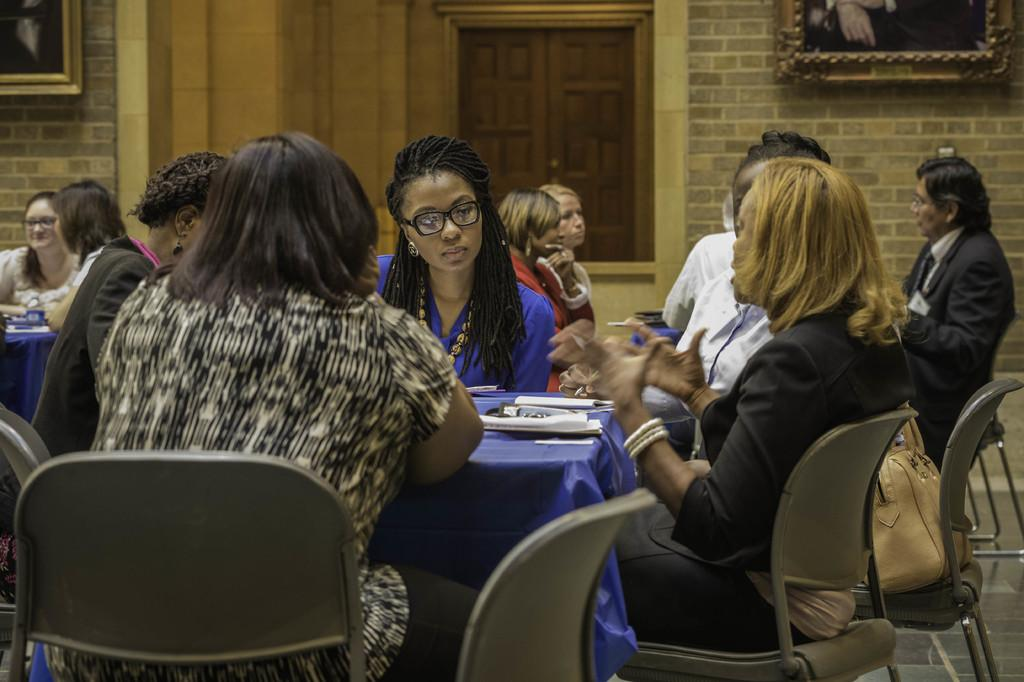What are the people in the image doing? The people in the image are sitting on chairs. What is on one of the chairs? There is a bag on one of the chairs. What can be seen on the table? Papers are present on a table. What is visible in the background of the image? There is a wall with frames and a window in the background. What is the floor like in the image? The floor is visible in the image. How many trees can be seen through the window in the image? There are no trees visible through the window in the image. What type of wheel is used by the people sitting on chairs in the image? There is no wheel present in the image; the people are sitting on chairs with legs. 